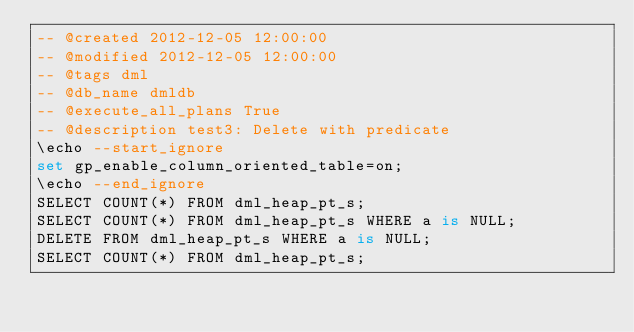<code> <loc_0><loc_0><loc_500><loc_500><_SQL_>-- @created 2012-12-05 12:00:00 
-- @modified 2012-12-05 12:00:00 
-- @tags dml 
-- @db_name dmldb
-- @execute_all_plans True
-- @description test3: Delete with predicate
\echo --start_ignore
set gp_enable_column_oriented_table=on;
\echo --end_ignore
SELECT COUNT(*) FROM dml_heap_pt_s;
SELECT COUNT(*) FROM dml_heap_pt_s WHERE a is NULL;
DELETE FROM dml_heap_pt_s WHERE a is NULL; 
SELECT COUNT(*) FROM dml_heap_pt_s;
</code> 